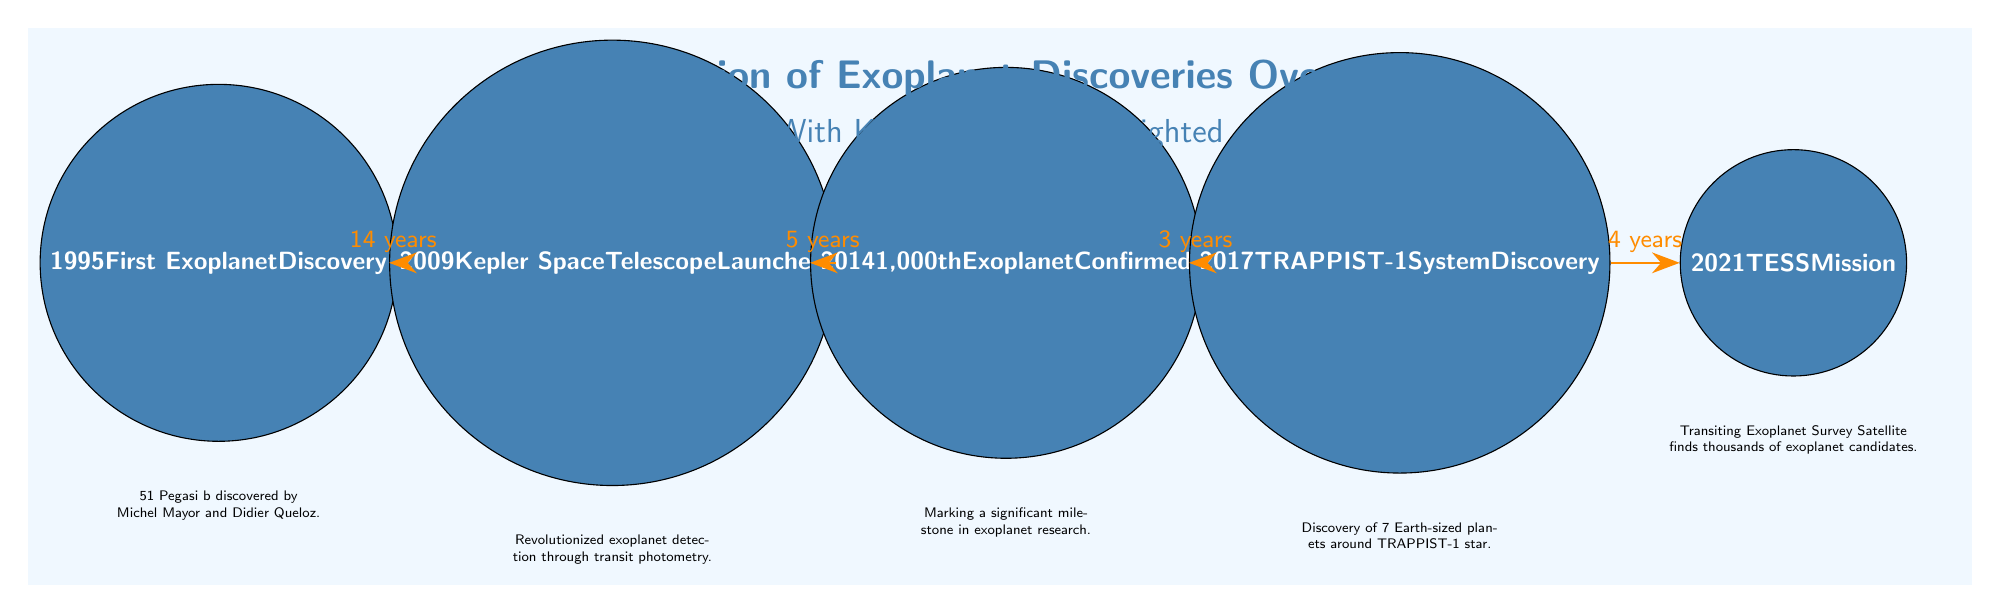What year marks the first exoplanet discovery? The first exoplanet discovery is marked by the event at the node labeled "1995". Therefore, the answer is straightforwardly the year mentioned there.
Answer: 1995 How many years passed between the launch of the Kepler Space Telescope and the confirmation of the 1,000th exoplanet? To find the answer, we look at the arrows connecting the nodes. The arrow from "2009" to "2014" indicates a span of "5 years".
Answer: 5 years What significant astronomical event occurred in 2017? The event in 2017 is represented by the node labeled "TRAPPIST-1 System Discovery". This provides direct reference to the significant discovery made that year.
Answer: TRAPPIST-1 System Discovery Which milestone was reached in 2014? The milestone indicated in the 2014 node is to confirm the "1,000th Exoplanet". This is explicitly stated in the node for that year.
Answer: 1,000th Exoplanet Confirmed What is the relationship between the first exoplanet discovery and the launch of the Kepler Space Telescope? The relationship is measured through the time difference of "14 years" shown on the arrow connecting the nodes "1995" and "2009". So, the time span can be read directly from the diagram.
Answer: 14 years Which space mission began in 2021, according to the diagram? The node labeled "2021" specifies the mission, which is the "TESS Mission", clearly indicating the launch of this particular endeavor.
Answer: TESS Mission How many significant milestones are highlighted in the diagram? By counting the nodes which represent key milestones, we see there are 5 nodes in total: one for each of the years 1995, 2009, 2014, 2017, and 2021.
Answer: 5 What discovery facilitated revolutionized exoplanet detection methods? The explanation is found in the description below the node labeled "2009", which informs us that the Kepler Space Telescope launched that year revolutionized detection through transit photometry. This is the only relevant milestone connected to detection methods.
Answer: Transit photometry What important discovery occurred in 2014? The node for 2014 states "1,000th Exoplanet Confirmed", which signifies a major achievement in discovering exoplanets during that year.
Answer: 1,000th Exoplanet Confirmed 